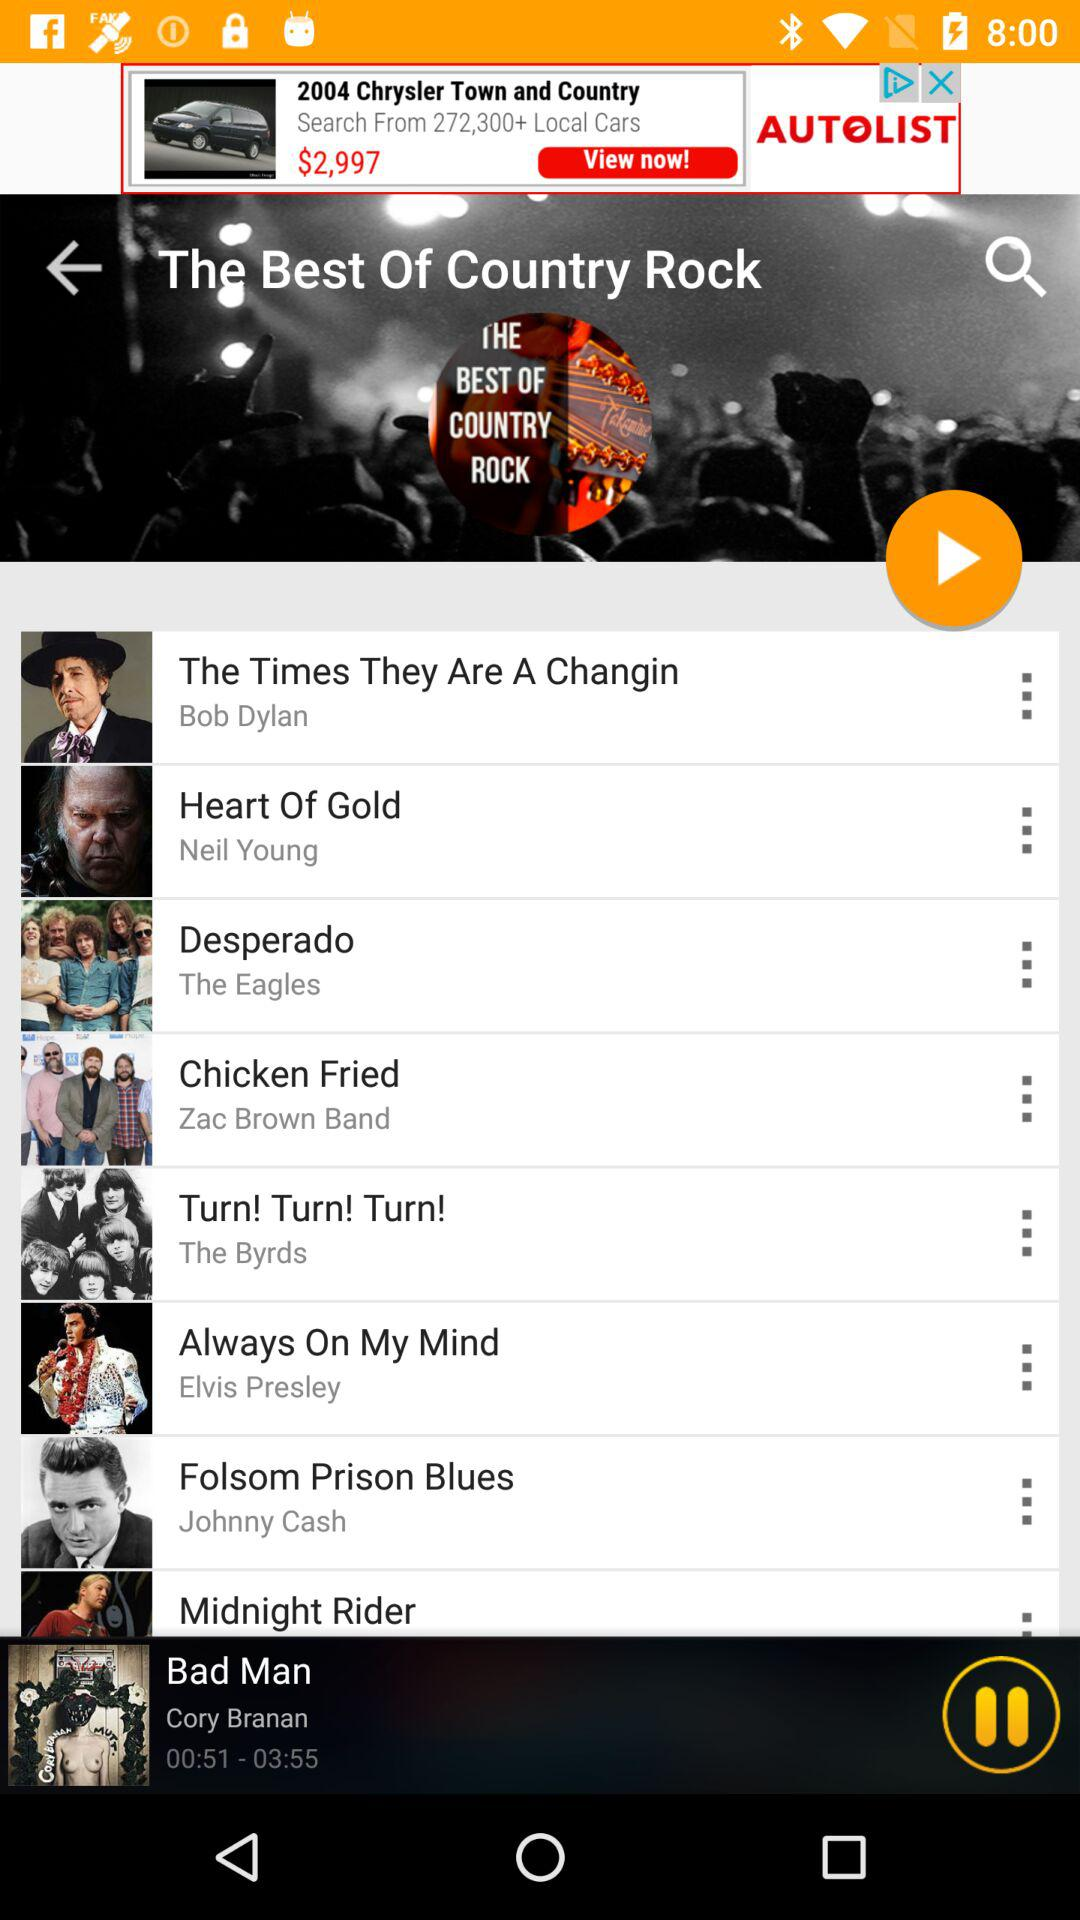Who is the singer of the song "Always On My Mind"? The singer of the song "Always On My Mind" is Elvis Presley. 